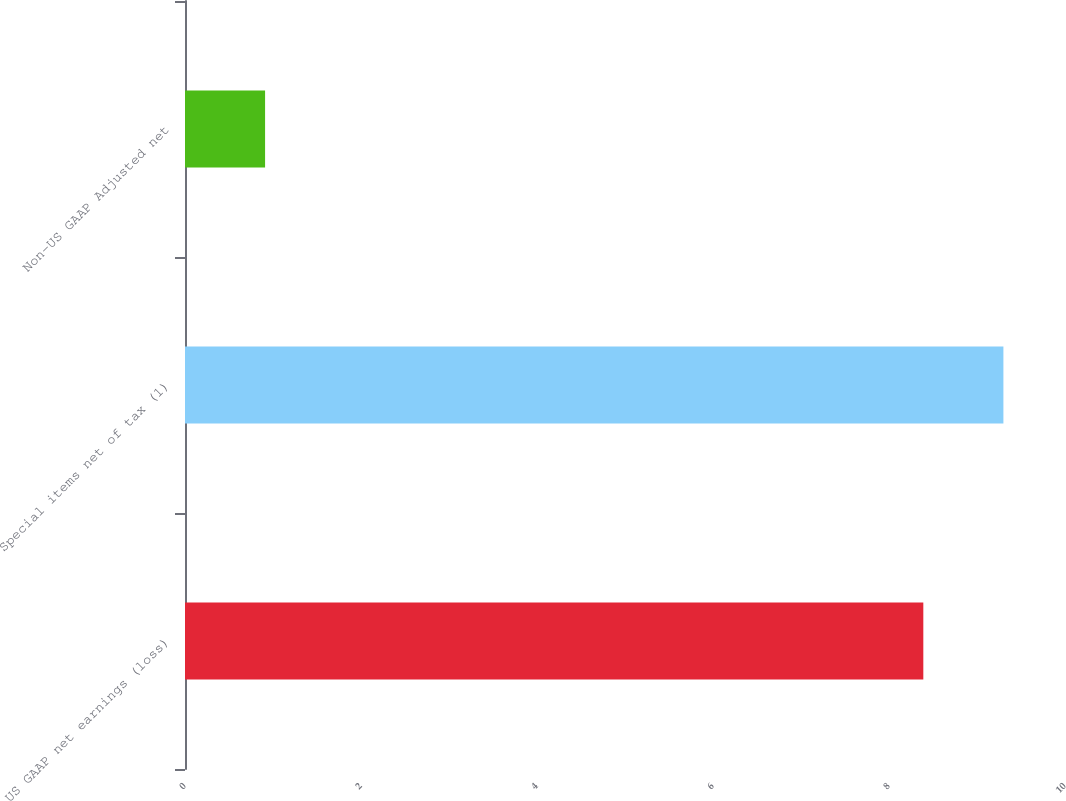Convert chart. <chart><loc_0><loc_0><loc_500><loc_500><bar_chart><fcel>US GAAP net earnings (loss)<fcel>Special items net of tax (1)<fcel>Non-US GAAP Adjusted net<nl><fcel>8.39<fcel>9.3<fcel>0.91<nl></chart> 